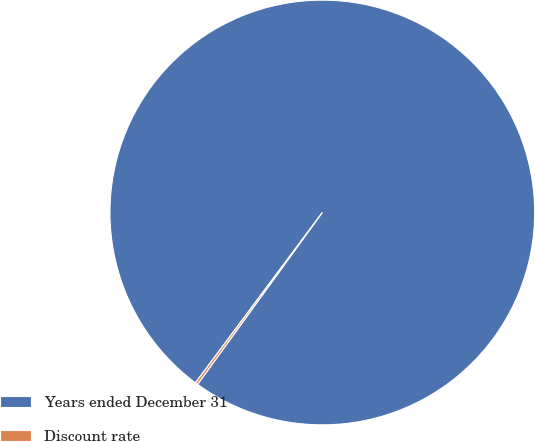Convert chart. <chart><loc_0><loc_0><loc_500><loc_500><pie_chart><fcel>Years ended December 31<fcel>Discount rate<nl><fcel>99.8%<fcel>0.2%<nl></chart> 